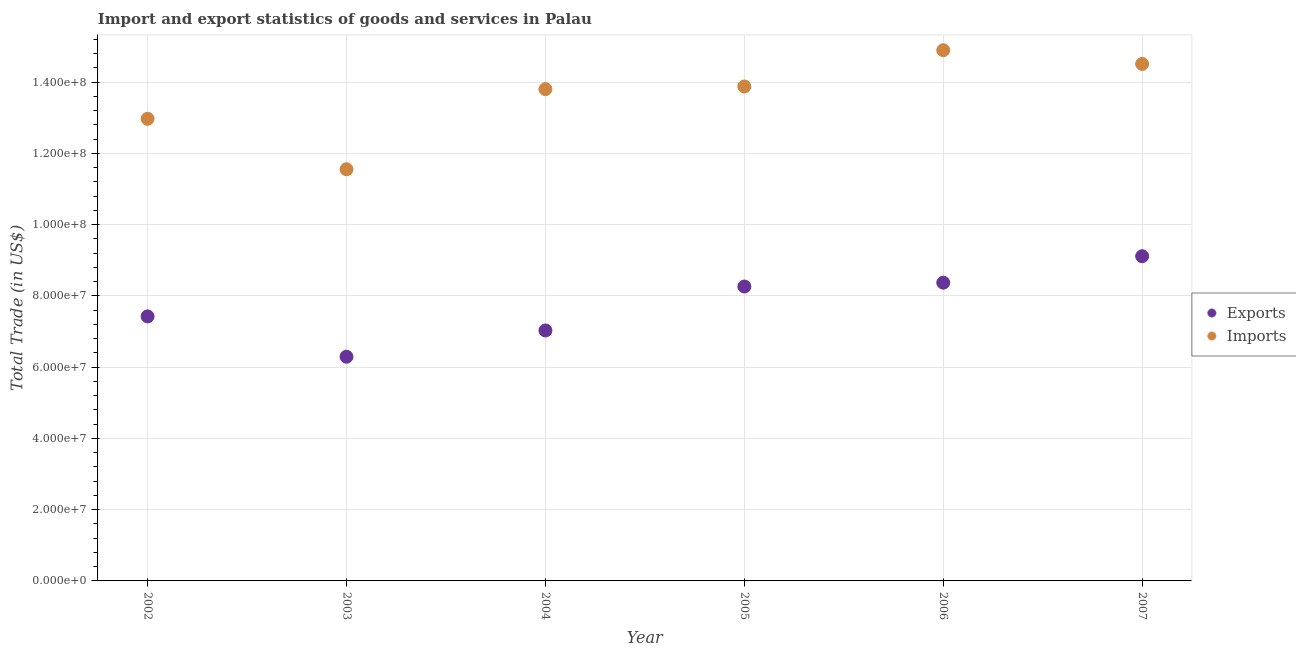How many different coloured dotlines are there?
Ensure brevity in your answer.  2. Is the number of dotlines equal to the number of legend labels?
Offer a very short reply. Yes. What is the imports of goods and services in 2003?
Keep it short and to the point. 1.16e+08. Across all years, what is the maximum imports of goods and services?
Your answer should be very brief. 1.49e+08. Across all years, what is the minimum imports of goods and services?
Ensure brevity in your answer.  1.16e+08. In which year was the imports of goods and services maximum?
Provide a succinct answer. 2006. What is the total export of goods and services in the graph?
Offer a terse response. 4.65e+08. What is the difference between the export of goods and services in 2003 and that in 2004?
Offer a terse response. -7.38e+06. What is the difference between the imports of goods and services in 2007 and the export of goods and services in 2006?
Offer a terse response. 6.14e+07. What is the average export of goods and services per year?
Make the answer very short. 7.75e+07. In the year 2002, what is the difference between the export of goods and services and imports of goods and services?
Give a very brief answer. -5.54e+07. What is the ratio of the export of goods and services in 2004 to that in 2007?
Offer a very short reply. 0.77. Is the difference between the export of goods and services in 2003 and 2007 greater than the difference between the imports of goods and services in 2003 and 2007?
Your answer should be compact. Yes. What is the difference between the highest and the second highest export of goods and services?
Offer a very short reply. 7.42e+06. What is the difference between the highest and the lowest imports of goods and services?
Your response must be concise. 3.34e+07. In how many years, is the export of goods and services greater than the average export of goods and services taken over all years?
Provide a short and direct response. 3. Is the imports of goods and services strictly greater than the export of goods and services over the years?
Your answer should be very brief. Yes. Is the export of goods and services strictly less than the imports of goods and services over the years?
Your answer should be very brief. Yes. What is the difference between two consecutive major ticks on the Y-axis?
Your response must be concise. 2.00e+07. Does the graph contain any zero values?
Your response must be concise. No. Where does the legend appear in the graph?
Provide a succinct answer. Center right. How are the legend labels stacked?
Ensure brevity in your answer.  Vertical. What is the title of the graph?
Offer a terse response. Import and export statistics of goods and services in Palau. Does "Females" appear as one of the legend labels in the graph?
Your answer should be very brief. No. What is the label or title of the X-axis?
Make the answer very short. Year. What is the label or title of the Y-axis?
Your answer should be compact. Total Trade (in US$). What is the Total Trade (in US$) of Exports in 2002?
Give a very brief answer. 7.42e+07. What is the Total Trade (in US$) of Imports in 2002?
Offer a very short reply. 1.30e+08. What is the Total Trade (in US$) of Exports in 2003?
Provide a short and direct response. 6.29e+07. What is the Total Trade (in US$) in Imports in 2003?
Offer a terse response. 1.16e+08. What is the Total Trade (in US$) of Exports in 2004?
Give a very brief answer. 7.03e+07. What is the Total Trade (in US$) in Imports in 2004?
Your answer should be compact. 1.38e+08. What is the Total Trade (in US$) of Exports in 2005?
Your answer should be compact. 8.26e+07. What is the Total Trade (in US$) in Imports in 2005?
Give a very brief answer. 1.39e+08. What is the Total Trade (in US$) of Exports in 2006?
Keep it short and to the point. 8.37e+07. What is the Total Trade (in US$) of Imports in 2006?
Keep it short and to the point. 1.49e+08. What is the Total Trade (in US$) in Exports in 2007?
Provide a short and direct response. 9.11e+07. What is the Total Trade (in US$) of Imports in 2007?
Give a very brief answer. 1.45e+08. Across all years, what is the maximum Total Trade (in US$) in Exports?
Provide a short and direct response. 9.11e+07. Across all years, what is the maximum Total Trade (in US$) of Imports?
Offer a terse response. 1.49e+08. Across all years, what is the minimum Total Trade (in US$) in Exports?
Give a very brief answer. 6.29e+07. Across all years, what is the minimum Total Trade (in US$) of Imports?
Your response must be concise. 1.16e+08. What is the total Total Trade (in US$) in Exports in the graph?
Provide a short and direct response. 4.65e+08. What is the total Total Trade (in US$) in Imports in the graph?
Ensure brevity in your answer.  8.16e+08. What is the difference between the Total Trade (in US$) of Exports in 2002 and that in 2003?
Make the answer very short. 1.13e+07. What is the difference between the Total Trade (in US$) of Imports in 2002 and that in 2003?
Offer a very short reply. 1.42e+07. What is the difference between the Total Trade (in US$) in Exports in 2002 and that in 2004?
Offer a terse response. 3.95e+06. What is the difference between the Total Trade (in US$) of Imports in 2002 and that in 2004?
Provide a short and direct response. -8.32e+06. What is the difference between the Total Trade (in US$) in Exports in 2002 and that in 2005?
Your answer should be compact. -8.38e+06. What is the difference between the Total Trade (in US$) of Imports in 2002 and that in 2005?
Make the answer very short. -9.07e+06. What is the difference between the Total Trade (in US$) in Exports in 2002 and that in 2006?
Make the answer very short. -9.46e+06. What is the difference between the Total Trade (in US$) of Imports in 2002 and that in 2006?
Give a very brief answer. -1.92e+07. What is the difference between the Total Trade (in US$) in Exports in 2002 and that in 2007?
Your answer should be very brief. -1.69e+07. What is the difference between the Total Trade (in US$) in Imports in 2002 and that in 2007?
Your response must be concise. -1.54e+07. What is the difference between the Total Trade (in US$) of Exports in 2003 and that in 2004?
Your answer should be very brief. -7.38e+06. What is the difference between the Total Trade (in US$) of Imports in 2003 and that in 2004?
Give a very brief answer. -2.25e+07. What is the difference between the Total Trade (in US$) in Exports in 2003 and that in 2005?
Your response must be concise. -1.97e+07. What is the difference between the Total Trade (in US$) in Imports in 2003 and that in 2005?
Provide a short and direct response. -2.32e+07. What is the difference between the Total Trade (in US$) in Exports in 2003 and that in 2006?
Provide a short and direct response. -2.08e+07. What is the difference between the Total Trade (in US$) in Imports in 2003 and that in 2006?
Your response must be concise. -3.34e+07. What is the difference between the Total Trade (in US$) in Exports in 2003 and that in 2007?
Your answer should be compact. -2.82e+07. What is the difference between the Total Trade (in US$) of Imports in 2003 and that in 2007?
Ensure brevity in your answer.  -2.95e+07. What is the difference between the Total Trade (in US$) in Exports in 2004 and that in 2005?
Give a very brief answer. -1.23e+07. What is the difference between the Total Trade (in US$) in Imports in 2004 and that in 2005?
Provide a succinct answer. -7.46e+05. What is the difference between the Total Trade (in US$) of Exports in 2004 and that in 2006?
Provide a succinct answer. -1.34e+07. What is the difference between the Total Trade (in US$) of Imports in 2004 and that in 2006?
Give a very brief answer. -1.09e+07. What is the difference between the Total Trade (in US$) in Exports in 2004 and that in 2007?
Keep it short and to the point. -2.08e+07. What is the difference between the Total Trade (in US$) of Imports in 2004 and that in 2007?
Offer a terse response. -7.07e+06. What is the difference between the Total Trade (in US$) in Exports in 2005 and that in 2006?
Keep it short and to the point. -1.08e+06. What is the difference between the Total Trade (in US$) of Imports in 2005 and that in 2006?
Your response must be concise. -1.02e+07. What is the difference between the Total Trade (in US$) in Exports in 2005 and that in 2007?
Make the answer very short. -8.50e+06. What is the difference between the Total Trade (in US$) in Imports in 2005 and that in 2007?
Give a very brief answer. -6.32e+06. What is the difference between the Total Trade (in US$) in Exports in 2006 and that in 2007?
Offer a very short reply. -7.42e+06. What is the difference between the Total Trade (in US$) in Imports in 2006 and that in 2007?
Your answer should be compact. 3.86e+06. What is the difference between the Total Trade (in US$) of Exports in 2002 and the Total Trade (in US$) of Imports in 2003?
Offer a terse response. -4.13e+07. What is the difference between the Total Trade (in US$) in Exports in 2002 and the Total Trade (in US$) in Imports in 2004?
Give a very brief answer. -6.38e+07. What is the difference between the Total Trade (in US$) of Exports in 2002 and the Total Trade (in US$) of Imports in 2005?
Give a very brief answer. -6.45e+07. What is the difference between the Total Trade (in US$) of Exports in 2002 and the Total Trade (in US$) of Imports in 2006?
Offer a very short reply. -7.47e+07. What is the difference between the Total Trade (in US$) in Exports in 2002 and the Total Trade (in US$) in Imports in 2007?
Offer a terse response. -7.08e+07. What is the difference between the Total Trade (in US$) of Exports in 2003 and the Total Trade (in US$) of Imports in 2004?
Provide a succinct answer. -7.51e+07. What is the difference between the Total Trade (in US$) of Exports in 2003 and the Total Trade (in US$) of Imports in 2005?
Make the answer very short. -7.58e+07. What is the difference between the Total Trade (in US$) in Exports in 2003 and the Total Trade (in US$) in Imports in 2006?
Offer a very short reply. -8.60e+07. What is the difference between the Total Trade (in US$) in Exports in 2003 and the Total Trade (in US$) in Imports in 2007?
Give a very brief answer. -8.22e+07. What is the difference between the Total Trade (in US$) of Exports in 2004 and the Total Trade (in US$) of Imports in 2005?
Give a very brief answer. -6.85e+07. What is the difference between the Total Trade (in US$) in Exports in 2004 and the Total Trade (in US$) in Imports in 2006?
Ensure brevity in your answer.  -7.86e+07. What is the difference between the Total Trade (in US$) of Exports in 2004 and the Total Trade (in US$) of Imports in 2007?
Your answer should be very brief. -7.48e+07. What is the difference between the Total Trade (in US$) of Exports in 2005 and the Total Trade (in US$) of Imports in 2006?
Ensure brevity in your answer.  -6.63e+07. What is the difference between the Total Trade (in US$) in Exports in 2005 and the Total Trade (in US$) in Imports in 2007?
Provide a short and direct response. -6.25e+07. What is the difference between the Total Trade (in US$) of Exports in 2006 and the Total Trade (in US$) of Imports in 2007?
Your answer should be compact. -6.14e+07. What is the average Total Trade (in US$) in Exports per year?
Your response must be concise. 7.75e+07. What is the average Total Trade (in US$) in Imports per year?
Offer a terse response. 1.36e+08. In the year 2002, what is the difference between the Total Trade (in US$) in Exports and Total Trade (in US$) in Imports?
Offer a terse response. -5.54e+07. In the year 2003, what is the difference between the Total Trade (in US$) in Exports and Total Trade (in US$) in Imports?
Your response must be concise. -5.26e+07. In the year 2004, what is the difference between the Total Trade (in US$) of Exports and Total Trade (in US$) of Imports?
Provide a succinct answer. -6.77e+07. In the year 2005, what is the difference between the Total Trade (in US$) of Exports and Total Trade (in US$) of Imports?
Offer a very short reply. -5.61e+07. In the year 2006, what is the difference between the Total Trade (in US$) of Exports and Total Trade (in US$) of Imports?
Offer a very short reply. -6.52e+07. In the year 2007, what is the difference between the Total Trade (in US$) in Exports and Total Trade (in US$) in Imports?
Make the answer very short. -5.40e+07. What is the ratio of the Total Trade (in US$) of Exports in 2002 to that in 2003?
Offer a very short reply. 1.18. What is the ratio of the Total Trade (in US$) in Imports in 2002 to that in 2003?
Ensure brevity in your answer.  1.12. What is the ratio of the Total Trade (in US$) in Exports in 2002 to that in 2004?
Your answer should be very brief. 1.06. What is the ratio of the Total Trade (in US$) in Imports in 2002 to that in 2004?
Your answer should be very brief. 0.94. What is the ratio of the Total Trade (in US$) in Exports in 2002 to that in 2005?
Give a very brief answer. 0.9. What is the ratio of the Total Trade (in US$) in Imports in 2002 to that in 2005?
Your answer should be very brief. 0.93. What is the ratio of the Total Trade (in US$) of Exports in 2002 to that in 2006?
Your answer should be compact. 0.89. What is the ratio of the Total Trade (in US$) in Imports in 2002 to that in 2006?
Keep it short and to the point. 0.87. What is the ratio of the Total Trade (in US$) in Exports in 2002 to that in 2007?
Ensure brevity in your answer.  0.81. What is the ratio of the Total Trade (in US$) in Imports in 2002 to that in 2007?
Make the answer very short. 0.89. What is the ratio of the Total Trade (in US$) in Exports in 2003 to that in 2004?
Make the answer very short. 0.9. What is the ratio of the Total Trade (in US$) of Imports in 2003 to that in 2004?
Make the answer very short. 0.84. What is the ratio of the Total Trade (in US$) of Exports in 2003 to that in 2005?
Your response must be concise. 0.76. What is the ratio of the Total Trade (in US$) of Imports in 2003 to that in 2005?
Your answer should be very brief. 0.83. What is the ratio of the Total Trade (in US$) of Exports in 2003 to that in 2006?
Provide a short and direct response. 0.75. What is the ratio of the Total Trade (in US$) in Imports in 2003 to that in 2006?
Provide a short and direct response. 0.78. What is the ratio of the Total Trade (in US$) in Exports in 2003 to that in 2007?
Keep it short and to the point. 0.69. What is the ratio of the Total Trade (in US$) in Imports in 2003 to that in 2007?
Ensure brevity in your answer.  0.8. What is the ratio of the Total Trade (in US$) of Exports in 2004 to that in 2005?
Ensure brevity in your answer.  0.85. What is the ratio of the Total Trade (in US$) of Imports in 2004 to that in 2005?
Give a very brief answer. 0.99. What is the ratio of the Total Trade (in US$) in Exports in 2004 to that in 2006?
Provide a succinct answer. 0.84. What is the ratio of the Total Trade (in US$) of Imports in 2004 to that in 2006?
Your answer should be compact. 0.93. What is the ratio of the Total Trade (in US$) of Exports in 2004 to that in 2007?
Provide a short and direct response. 0.77. What is the ratio of the Total Trade (in US$) of Imports in 2004 to that in 2007?
Provide a succinct answer. 0.95. What is the ratio of the Total Trade (in US$) in Exports in 2005 to that in 2006?
Provide a short and direct response. 0.99. What is the ratio of the Total Trade (in US$) in Imports in 2005 to that in 2006?
Make the answer very short. 0.93. What is the ratio of the Total Trade (in US$) of Exports in 2005 to that in 2007?
Keep it short and to the point. 0.91. What is the ratio of the Total Trade (in US$) of Imports in 2005 to that in 2007?
Offer a very short reply. 0.96. What is the ratio of the Total Trade (in US$) in Exports in 2006 to that in 2007?
Offer a terse response. 0.92. What is the ratio of the Total Trade (in US$) of Imports in 2006 to that in 2007?
Keep it short and to the point. 1.03. What is the difference between the highest and the second highest Total Trade (in US$) in Exports?
Make the answer very short. 7.42e+06. What is the difference between the highest and the second highest Total Trade (in US$) in Imports?
Offer a very short reply. 3.86e+06. What is the difference between the highest and the lowest Total Trade (in US$) in Exports?
Offer a terse response. 2.82e+07. What is the difference between the highest and the lowest Total Trade (in US$) in Imports?
Your response must be concise. 3.34e+07. 